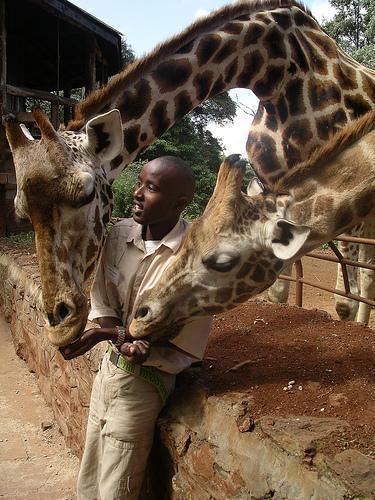How many giraffes are there?
Give a very brief answer. 2. 